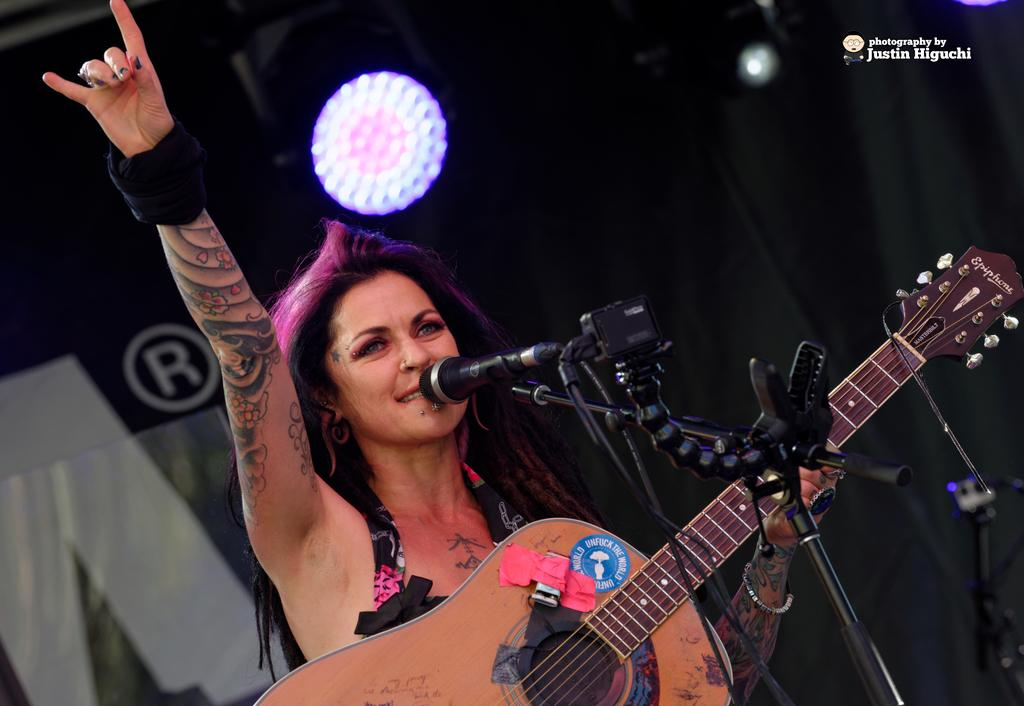What is the main subject of the image? The main subject of the image is a woman. What is the woman doing in the image? The woman is standing and holding a guitar in her hand. Is the woman using any equipment in the image? Yes, the woman is speaking into a microphone in the image. Where is the microphone positioned in relation to the woman? The microphone is in front of her. What is the woman's reaction to the disgusting thing she found in her guitar case? There is no indication of any disgusting thing or the woman's reaction to it in the image. 